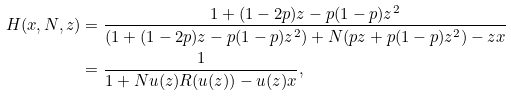Convert formula to latex. <formula><loc_0><loc_0><loc_500><loc_500>H ( x , N , z ) & = \frac { 1 + ( 1 - 2 p ) z - p ( 1 - p ) z ^ { 2 } } { ( 1 + ( 1 - 2 p ) z - p ( 1 - p ) z ^ { 2 } ) + N ( p z + p ( 1 - p ) z ^ { 2 } ) - z x } \\ & = \frac { 1 } { 1 + N u ( z ) R ( u ( z ) ) - u ( z ) x } ,</formula> 